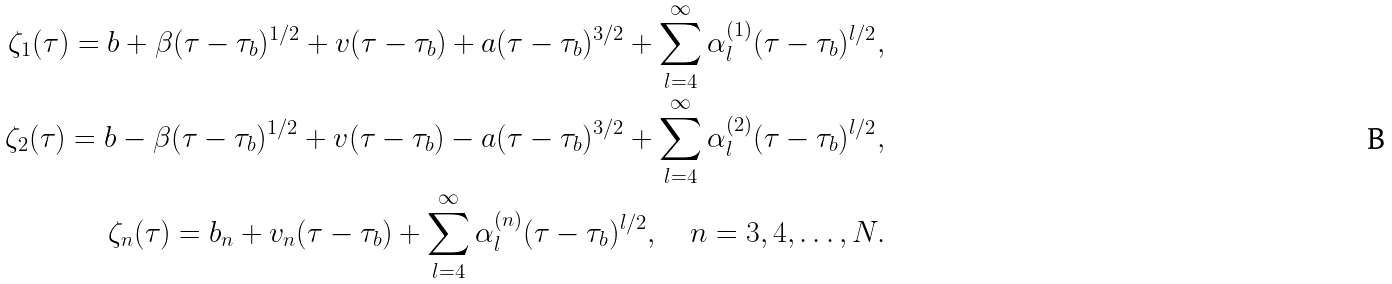<formula> <loc_0><loc_0><loc_500><loc_500>\zeta _ { 1 } ( \tau ) = b + \beta ( \tau - \tau _ { b } ) ^ { 1 / 2 } + v ( \tau - \tau _ { b } ) + a ( \tau - \tau _ { b } ) ^ { 3 / 2 } + \sum _ { l = 4 } ^ { \infty } \alpha _ { l } ^ { ( 1 ) } ( \tau - \tau _ { b } ) ^ { l / 2 } , \\ \zeta _ { 2 } ( \tau ) = b - \beta ( \tau - \tau _ { b } ) ^ { 1 / 2 } + v ( \tau - \tau _ { b } ) - a ( \tau - \tau _ { b } ) ^ { 3 / 2 } + \sum _ { l = 4 } ^ { \infty } \alpha _ { l } ^ { ( 2 ) } ( \tau - \tau _ { b } ) ^ { l / 2 } , \\ \zeta _ { n } ( \tau ) = b _ { n } + v _ { n } ( \tau - \tau _ { b } ) + \sum _ { l = 4 } ^ { \infty } \alpha _ { l } ^ { ( n ) } ( \tau - \tau _ { b } ) ^ { l / 2 } , \quad n = 3 , 4 , \dots , N .</formula> 